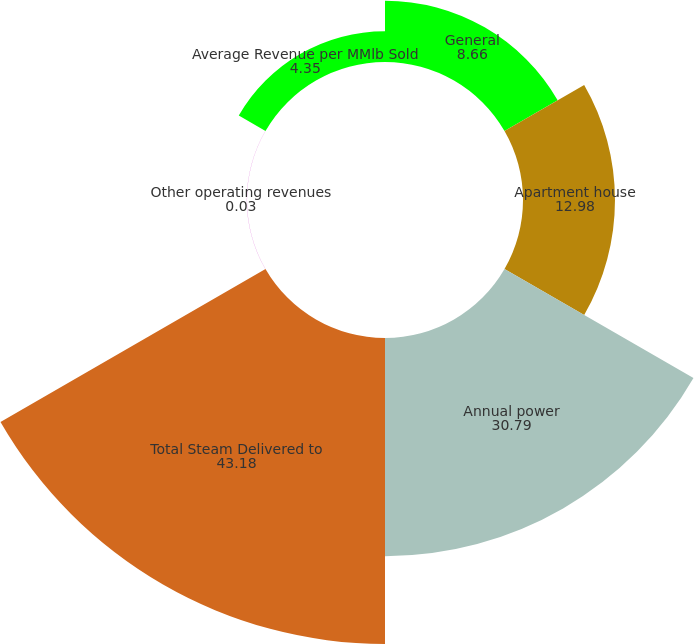Convert chart to OTSL. <chart><loc_0><loc_0><loc_500><loc_500><pie_chart><fcel>General<fcel>Apartment house<fcel>Annual power<fcel>Total Steam Delivered to<fcel>Other operating revenues<fcel>Average Revenue per MMlb Sold<nl><fcel>8.66%<fcel>12.98%<fcel>30.79%<fcel>43.18%<fcel>0.03%<fcel>4.35%<nl></chart> 